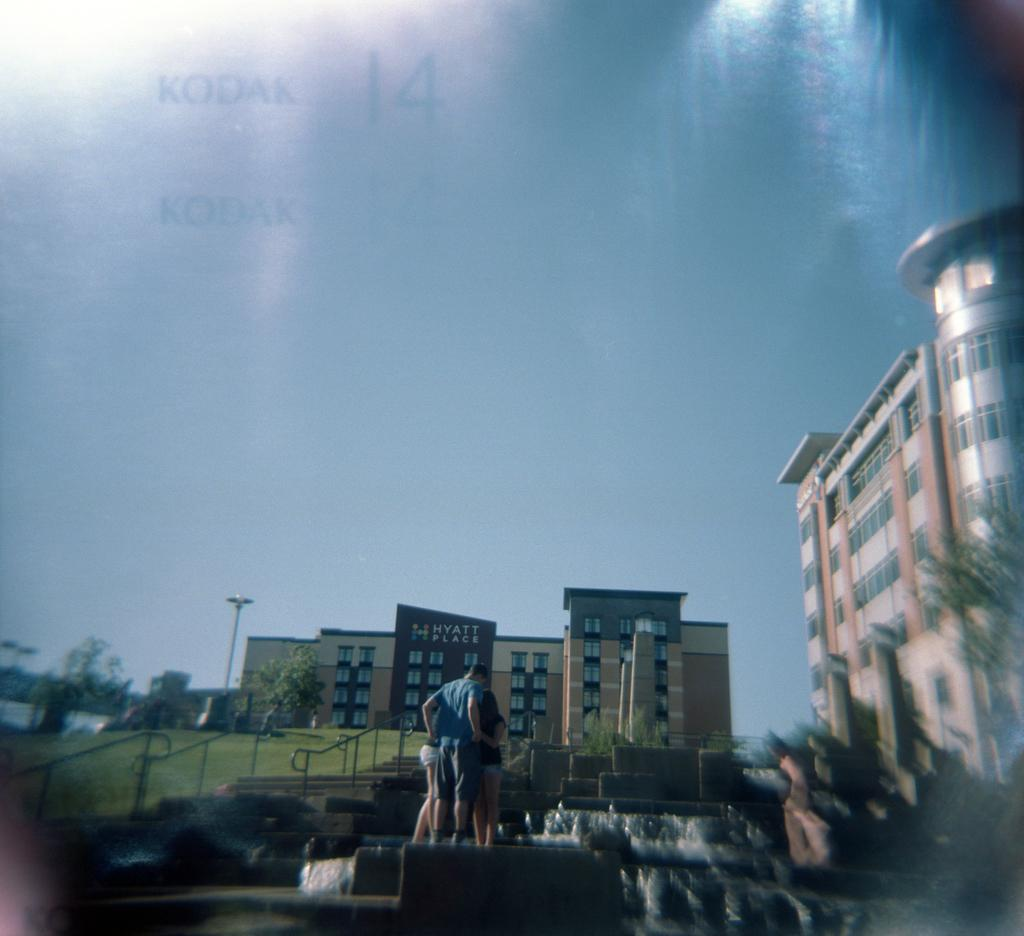How many people are in the image? There are three persons standing in the middle of the image. What can be seen in the background of the image? There is a waterfall, buildings, trees, a pole, and clouds in the sky in the background of the image. What type of bottle is being used in the war depicted in the image? There is no war or bottle present in the image. 